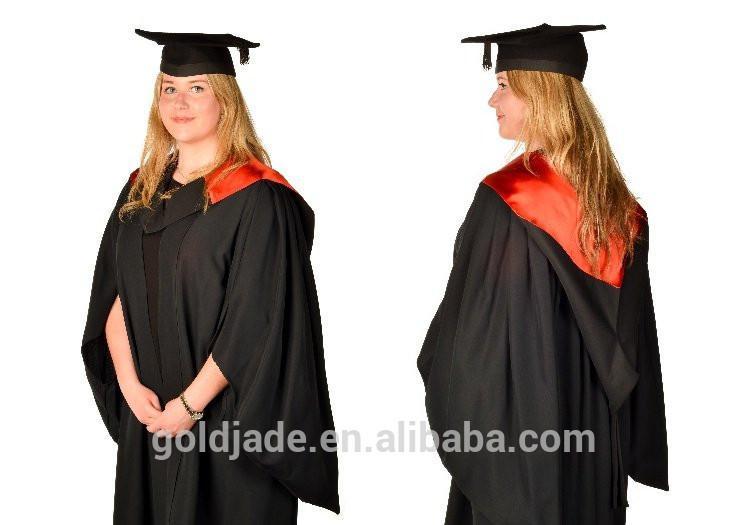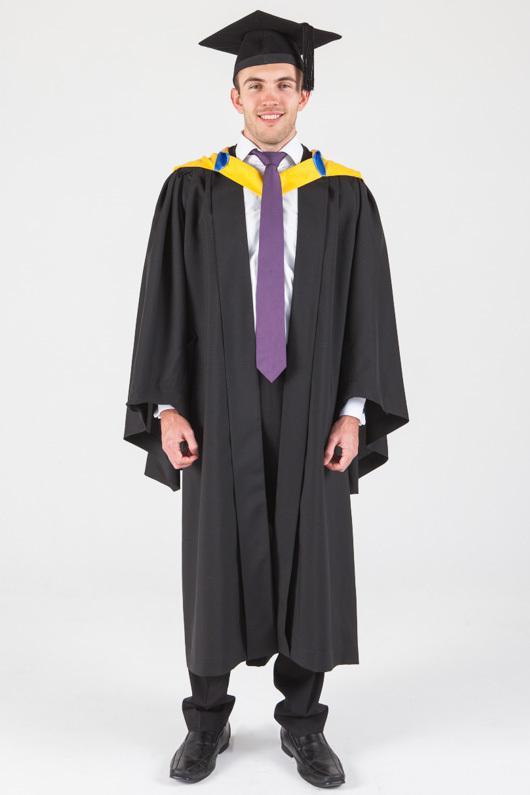The first image is the image on the left, the second image is the image on the right. Examine the images to the left and right. Is the description "A young girl wears a blue graduation robe and cap in one image." accurate? Answer yes or no. No. The first image is the image on the left, the second image is the image on the right. Considering the images on both sides, is "Two people are dressed in a blue graduation cap and blue graduation gown" valid? Answer yes or no. No. 